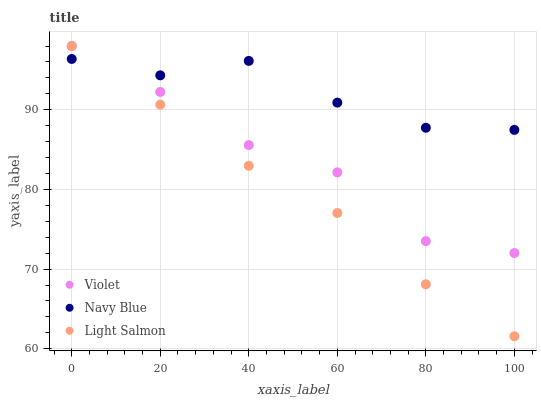Does Light Salmon have the minimum area under the curve?
Answer yes or no. Yes. Does Navy Blue have the maximum area under the curve?
Answer yes or no. Yes. Does Violet have the minimum area under the curve?
Answer yes or no. No. Does Violet have the maximum area under the curve?
Answer yes or no. No. Is Light Salmon the smoothest?
Answer yes or no. Yes. Is Violet the roughest?
Answer yes or no. Yes. Is Violet the smoothest?
Answer yes or no. No. Is Light Salmon the roughest?
Answer yes or no. No. Does Light Salmon have the lowest value?
Answer yes or no. Yes. Does Violet have the lowest value?
Answer yes or no. No. Does Light Salmon have the highest value?
Answer yes or no. Yes. Does Violet have the highest value?
Answer yes or no. No. Does Navy Blue intersect Light Salmon?
Answer yes or no. Yes. Is Navy Blue less than Light Salmon?
Answer yes or no. No. Is Navy Blue greater than Light Salmon?
Answer yes or no. No. 